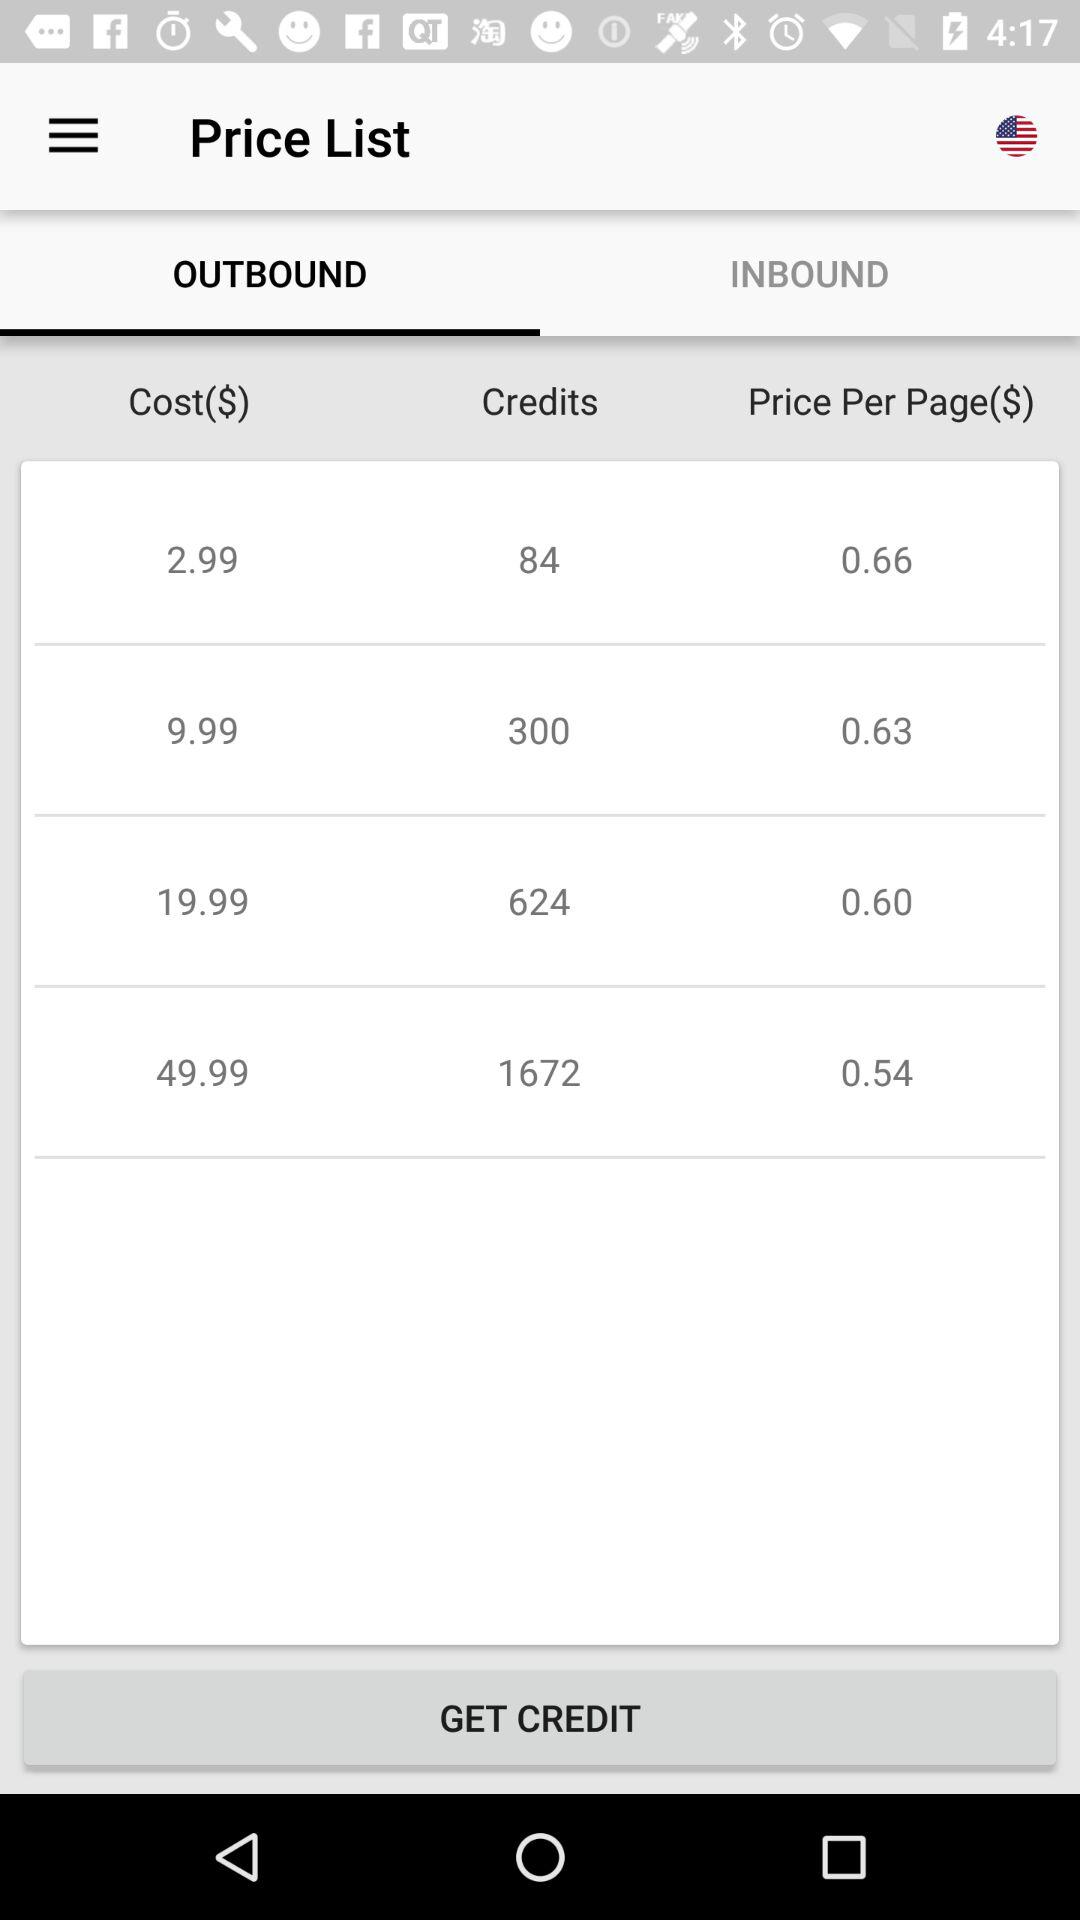What is the price of 624 credits? The price of 624 credits is $19.99. 